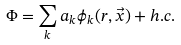Convert formula to latex. <formula><loc_0><loc_0><loc_500><loc_500>\Phi = \sum _ { k } a _ { k } \phi _ { k } ( r , \vec { x } ) + h . c .</formula> 